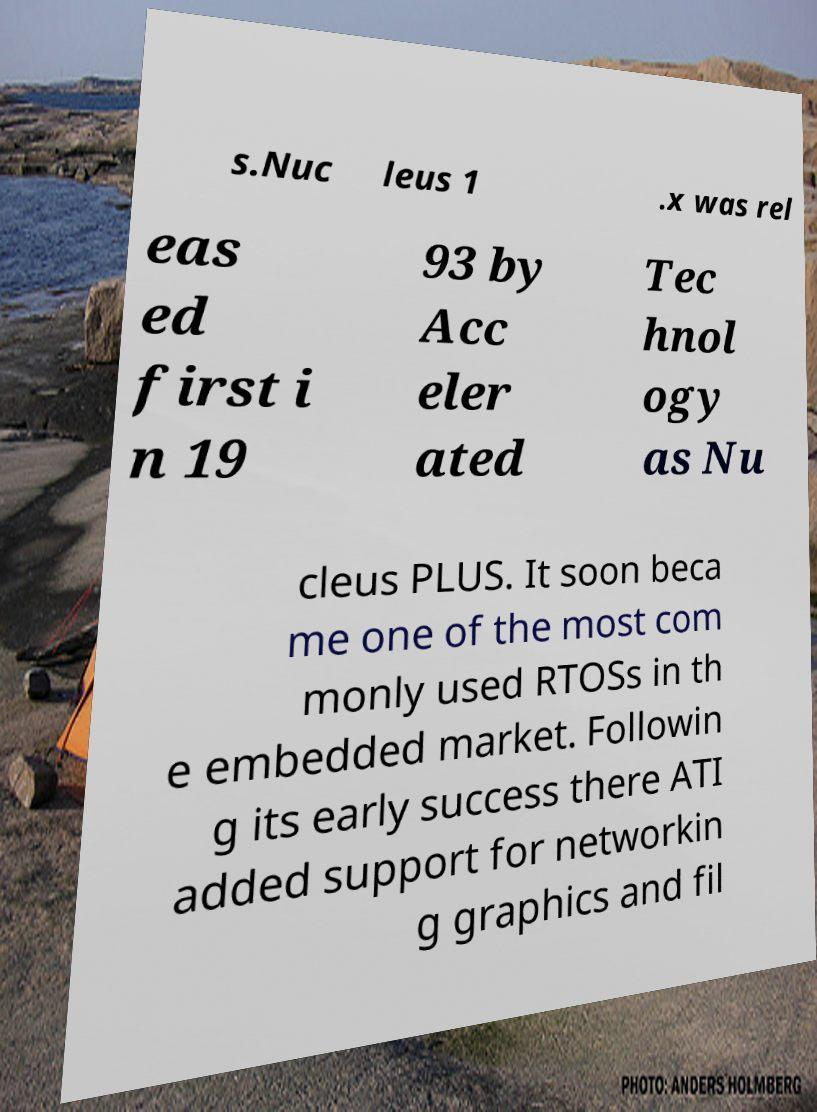Please read and relay the text visible in this image. What does it say? s.Nuc leus 1 .x was rel eas ed first i n 19 93 by Acc eler ated Tec hnol ogy as Nu cleus PLUS. It soon beca me one of the most com monly used RTOSs in th e embedded market. Followin g its early success there ATI added support for networkin g graphics and fil 